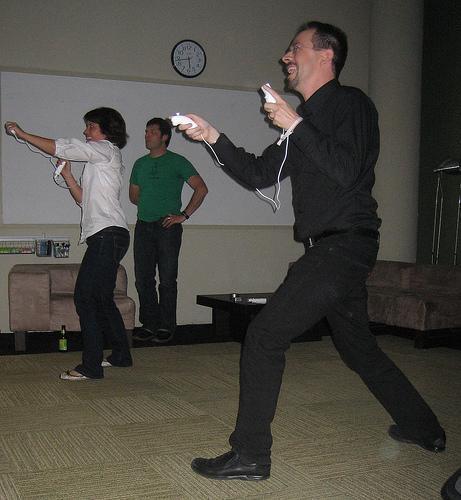How many people are playing?
Give a very brief answer. 2. 